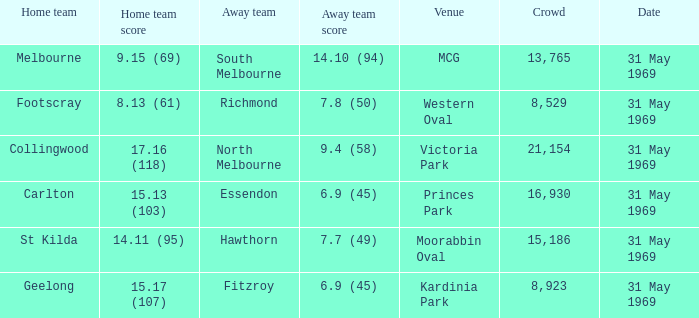Who was the home team in the game where North Melbourne was the away team? 17.16 (118). 